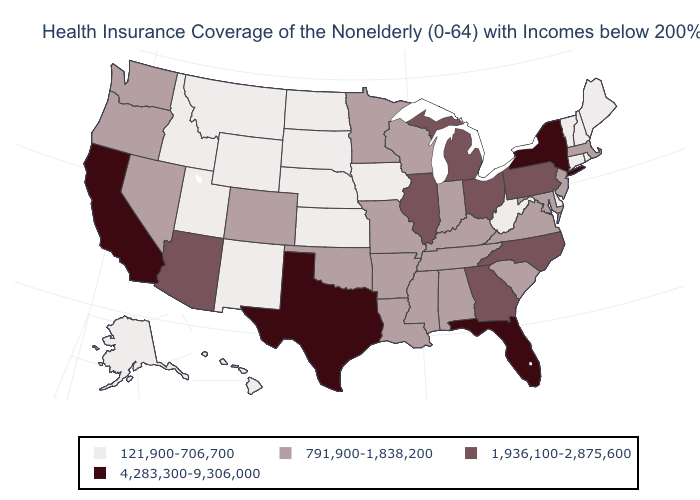Name the states that have a value in the range 121,900-706,700?
Answer briefly. Alaska, Connecticut, Delaware, Hawaii, Idaho, Iowa, Kansas, Maine, Montana, Nebraska, New Hampshire, New Mexico, North Dakota, Rhode Island, South Dakota, Utah, Vermont, West Virginia, Wyoming. Is the legend a continuous bar?
Give a very brief answer. No. Name the states that have a value in the range 4,283,300-9,306,000?
Keep it brief. California, Florida, New York, Texas. Name the states that have a value in the range 4,283,300-9,306,000?
Give a very brief answer. California, Florida, New York, Texas. Which states have the lowest value in the West?
Quick response, please. Alaska, Hawaii, Idaho, Montana, New Mexico, Utah, Wyoming. Among the states that border Nebraska , which have the highest value?
Quick response, please. Colorado, Missouri. Does Alaska have the lowest value in the West?
Quick response, please. Yes. What is the lowest value in the USA?
Concise answer only. 121,900-706,700. Which states have the highest value in the USA?
Short answer required. California, Florida, New York, Texas. What is the value of Rhode Island?
Quick response, please. 121,900-706,700. Does Illinois have the lowest value in the USA?
Keep it brief. No. Among the states that border Ohio , does West Virginia have the lowest value?
Keep it brief. Yes. Name the states that have a value in the range 4,283,300-9,306,000?
Quick response, please. California, Florida, New York, Texas. Name the states that have a value in the range 121,900-706,700?
Concise answer only. Alaska, Connecticut, Delaware, Hawaii, Idaho, Iowa, Kansas, Maine, Montana, Nebraska, New Hampshire, New Mexico, North Dakota, Rhode Island, South Dakota, Utah, Vermont, West Virginia, Wyoming. Does the map have missing data?
Give a very brief answer. No. 